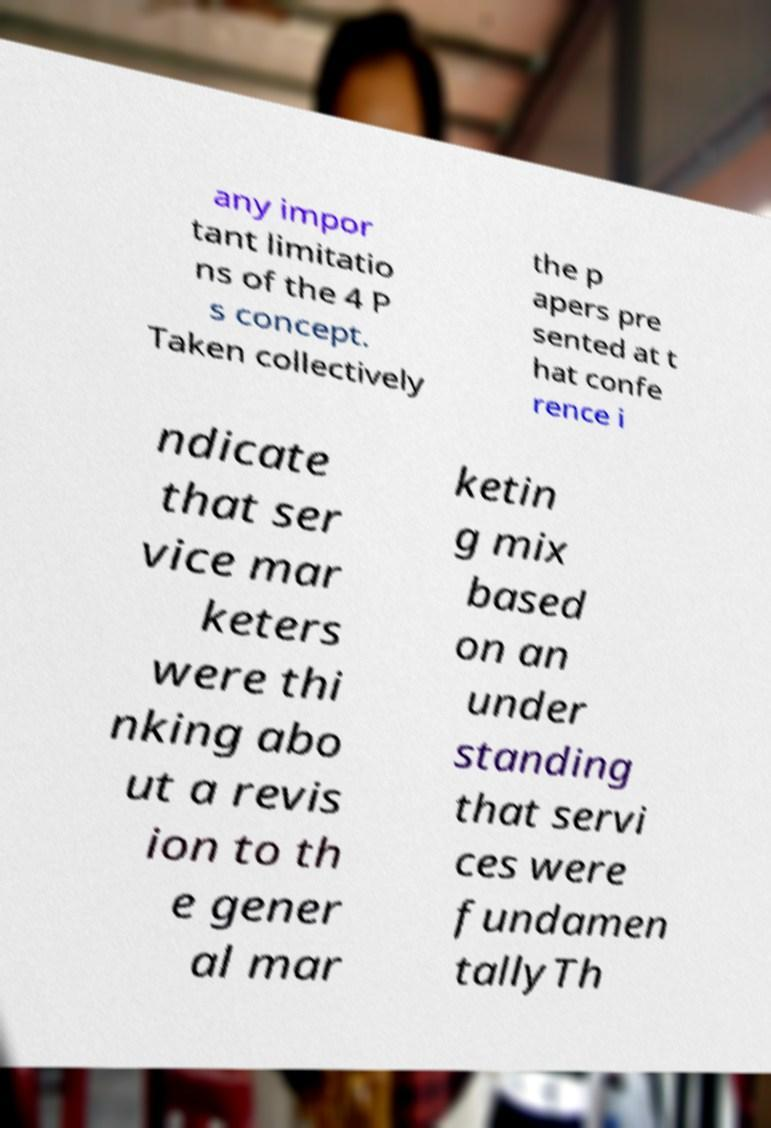There's text embedded in this image that I need extracted. Can you transcribe it verbatim? any impor tant limitatio ns of the 4 P s concept. Taken collectively the p apers pre sented at t hat confe rence i ndicate that ser vice mar keters were thi nking abo ut a revis ion to th e gener al mar ketin g mix based on an under standing that servi ces were fundamen tallyTh 